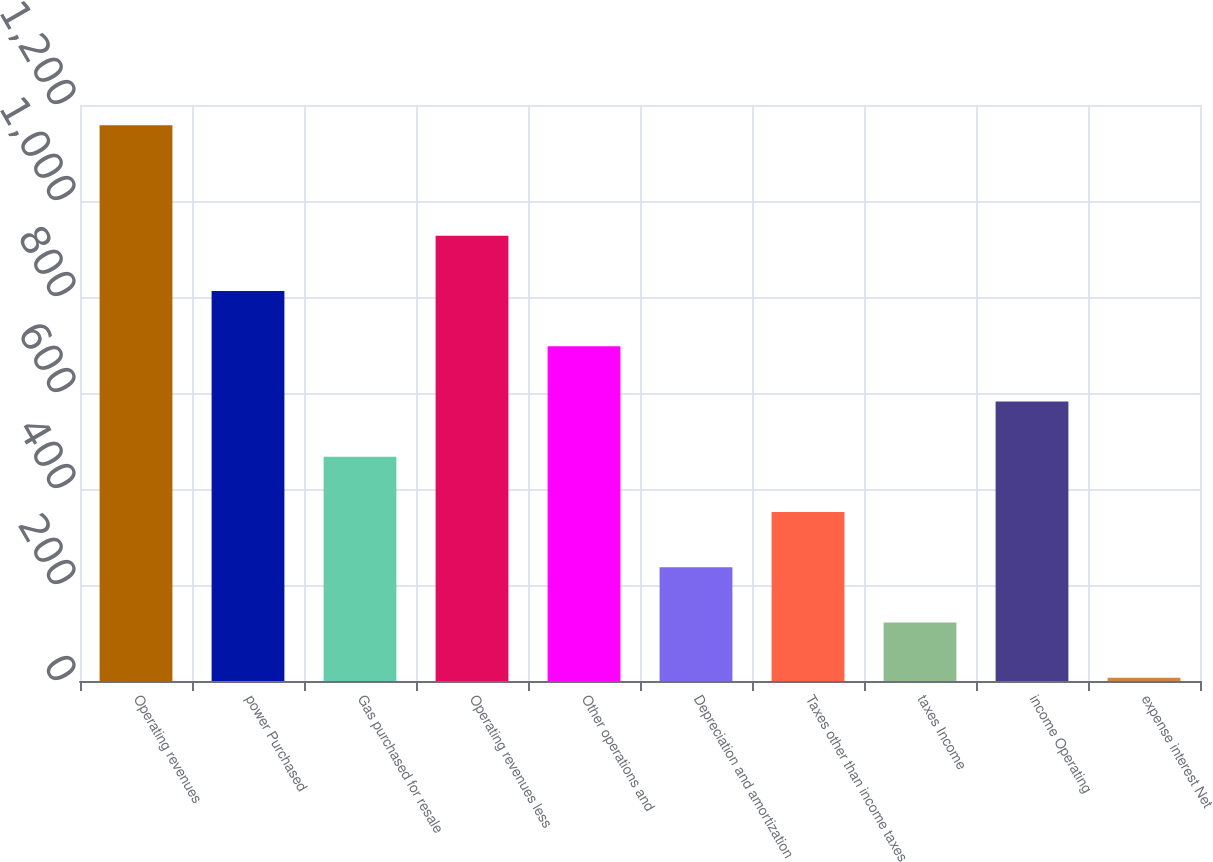Convert chart. <chart><loc_0><loc_0><loc_500><loc_500><bar_chart><fcel>Operating revenues<fcel>power Purchased<fcel>Gas purchased for resale<fcel>Operating revenues less<fcel>Other operations and<fcel>Depreciation and amortization<fcel>Taxes other than income taxes<fcel>taxes Income<fcel>income Operating<fcel>expense interest Net<nl><fcel>1158<fcel>812.7<fcel>467.4<fcel>927.8<fcel>697.6<fcel>237.2<fcel>352.3<fcel>122.1<fcel>582.5<fcel>7<nl></chart> 